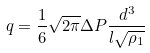<formula> <loc_0><loc_0><loc_500><loc_500>q = \frac { 1 } { 6 } \sqrt { 2 \pi } \Delta P \frac { d ^ { 3 } } { l \sqrt { \rho _ { 1 } } }</formula> 